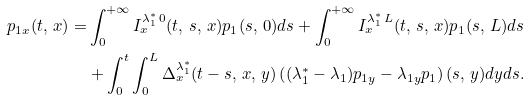<formula> <loc_0><loc_0><loc_500><loc_500>p _ { 1 x } ( t , \, x ) = & \int _ { 0 } ^ { + \infty } I _ { x } ^ { \lambda _ { 1 } ^ { \ast } \, 0 } ( t , \, s , \, x ) p _ { 1 } ( s , \, 0 ) d s + \int _ { 0 } ^ { + \infty } I _ { x } ^ { \lambda _ { 1 } ^ { \ast } \, L } ( t , \, s , \, x ) p _ { 1 } ( s , \, L ) d s \\ & + \int _ { 0 } ^ { t } \int _ { 0 } ^ { L } \Delta _ { x } ^ { \lambda _ { 1 } ^ { \ast } } ( t - s , \, x , \, y ) \left ( ( \lambda _ { 1 } ^ { \ast } - \lambda _ { 1 } ) p _ { 1 y } - \lambda _ { 1 y } p _ { 1 } \right ) ( s , \, y ) d y d s . \\</formula> 